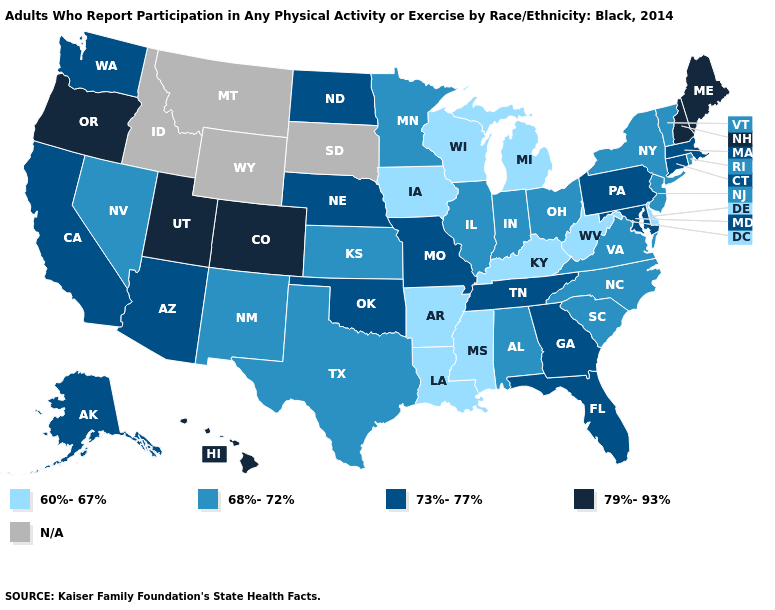How many symbols are there in the legend?
Keep it brief. 5. What is the lowest value in the Northeast?
Write a very short answer. 68%-72%. Name the states that have a value in the range 60%-67%?
Keep it brief. Arkansas, Delaware, Iowa, Kentucky, Louisiana, Michigan, Mississippi, West Virginia, Wisconsin. How many symbols are there in the legend?
Be succinct. 5. Name the states that have a value in the range 79%-93%?
Concise answer only. Colorado, Hawaii, Maine, New Hampshire, Oregon, Utah. What is the value of Alaska?
Concise answer only. 73%-77%. Does Hawaii have the highest value in the USA?
Quick response, please. Yes. Name the states that have a value in the range 60%-67%?
Write a very short answer. Arkansas, Delaware, Iowa, Kentucky, Louisiana, Michigan, Mississippi, West Virginia, Wisconsin. How many symbols are there in the legend?
Short answer required. 5. What is the highest value in the USA?
Write a very short answer. 79%-93%. Among the states that border Connecticut , does Massachusetts have the highest value?
Quick response, please. Yes. What is the value of North Carolina?
Write a very short answer. 68%-72%. What is the lowest value in states that border Nebraska?
Be succinct. 60%-67%. Does Alabama have the highest value in the USA?
Keep it brief. No. Name the states that have a value in the range 79%-93%?
Concise answer only. Colorado, Hawaii, Maine, New Hampshire, Oregon, Utah. 